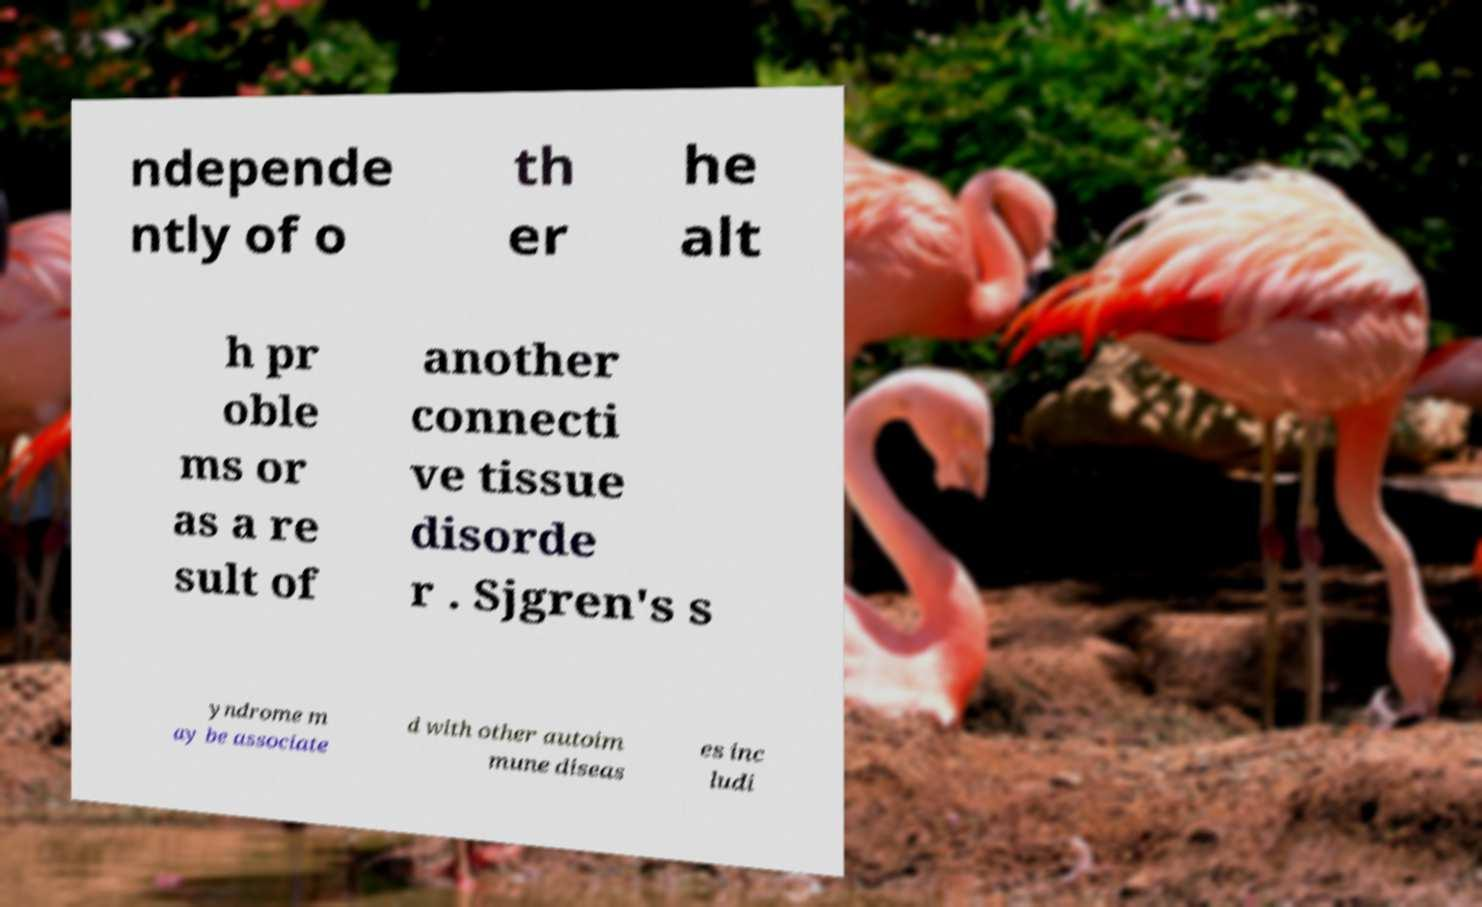There's text embedded in this image that I need extracted. Can you transcribe it verbatim? ndepende ntly of o th er he alt h pr oble ms or as a re sult of another connecti ve tissue disorde r . Sjgren's s yndrome m ay be associate d with other autoim mune diseas es inc ludi 